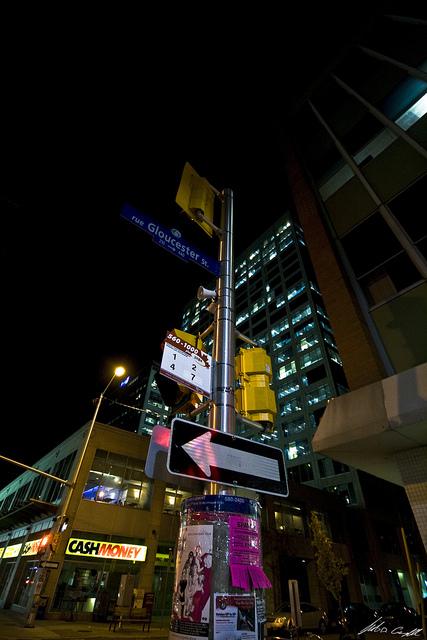Is it day or night time?
Keep it brief. Night. At what angle was the picture taken?
Be succinct. Lower. Which way can traffic not turn?
Short answer required. Right. What time is this?
Quick response, please. Night. 